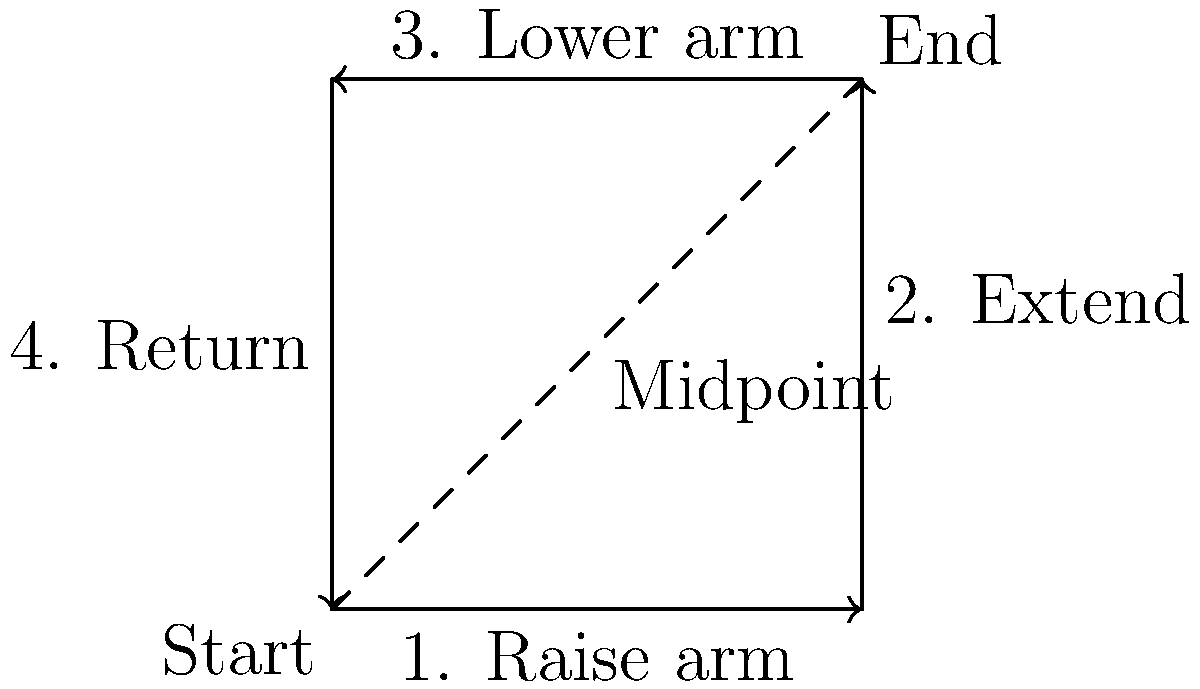In this physical therapy exercise diagram for arm movement, what is the significance of the dashed line connecting the "Start" and "End" points? To understand the significance of the dashed line in this physical therapy exercise diagram, let's analyze it step-by-step:

1. The diagram shows a square path for arm movement, with arrows indicating the direction of motion.
2. The exercise starts at the bottom-left corner (labeled "Start") and ends at the top-right corner (labeled "End").
3. The path is divided into four steps:
   a. Raise arm (moving right)
   b. Extend (moving up)
   c. Lower arm (moving left)
   d. Return (moving down)
4. The dashed line connects the "Start" and "End" points diagonally across the square.
5. In geometry, the diagonal of a square represents the shortest distance between opposite corners.
6. In the context of physical therapy, this diagonal line represents:
   a. The most direct path between the start and end positions
   b. A potential goal for the patient to work towards as they progress in their recovery
   c. A visual representation of the range of motion the patient aims to achieve

The dashed line, therefore, signifies the ideal motion path that the patient should strive for as they improve their arm mobility and strength through the exercise.
Answer: Ideal motion path 